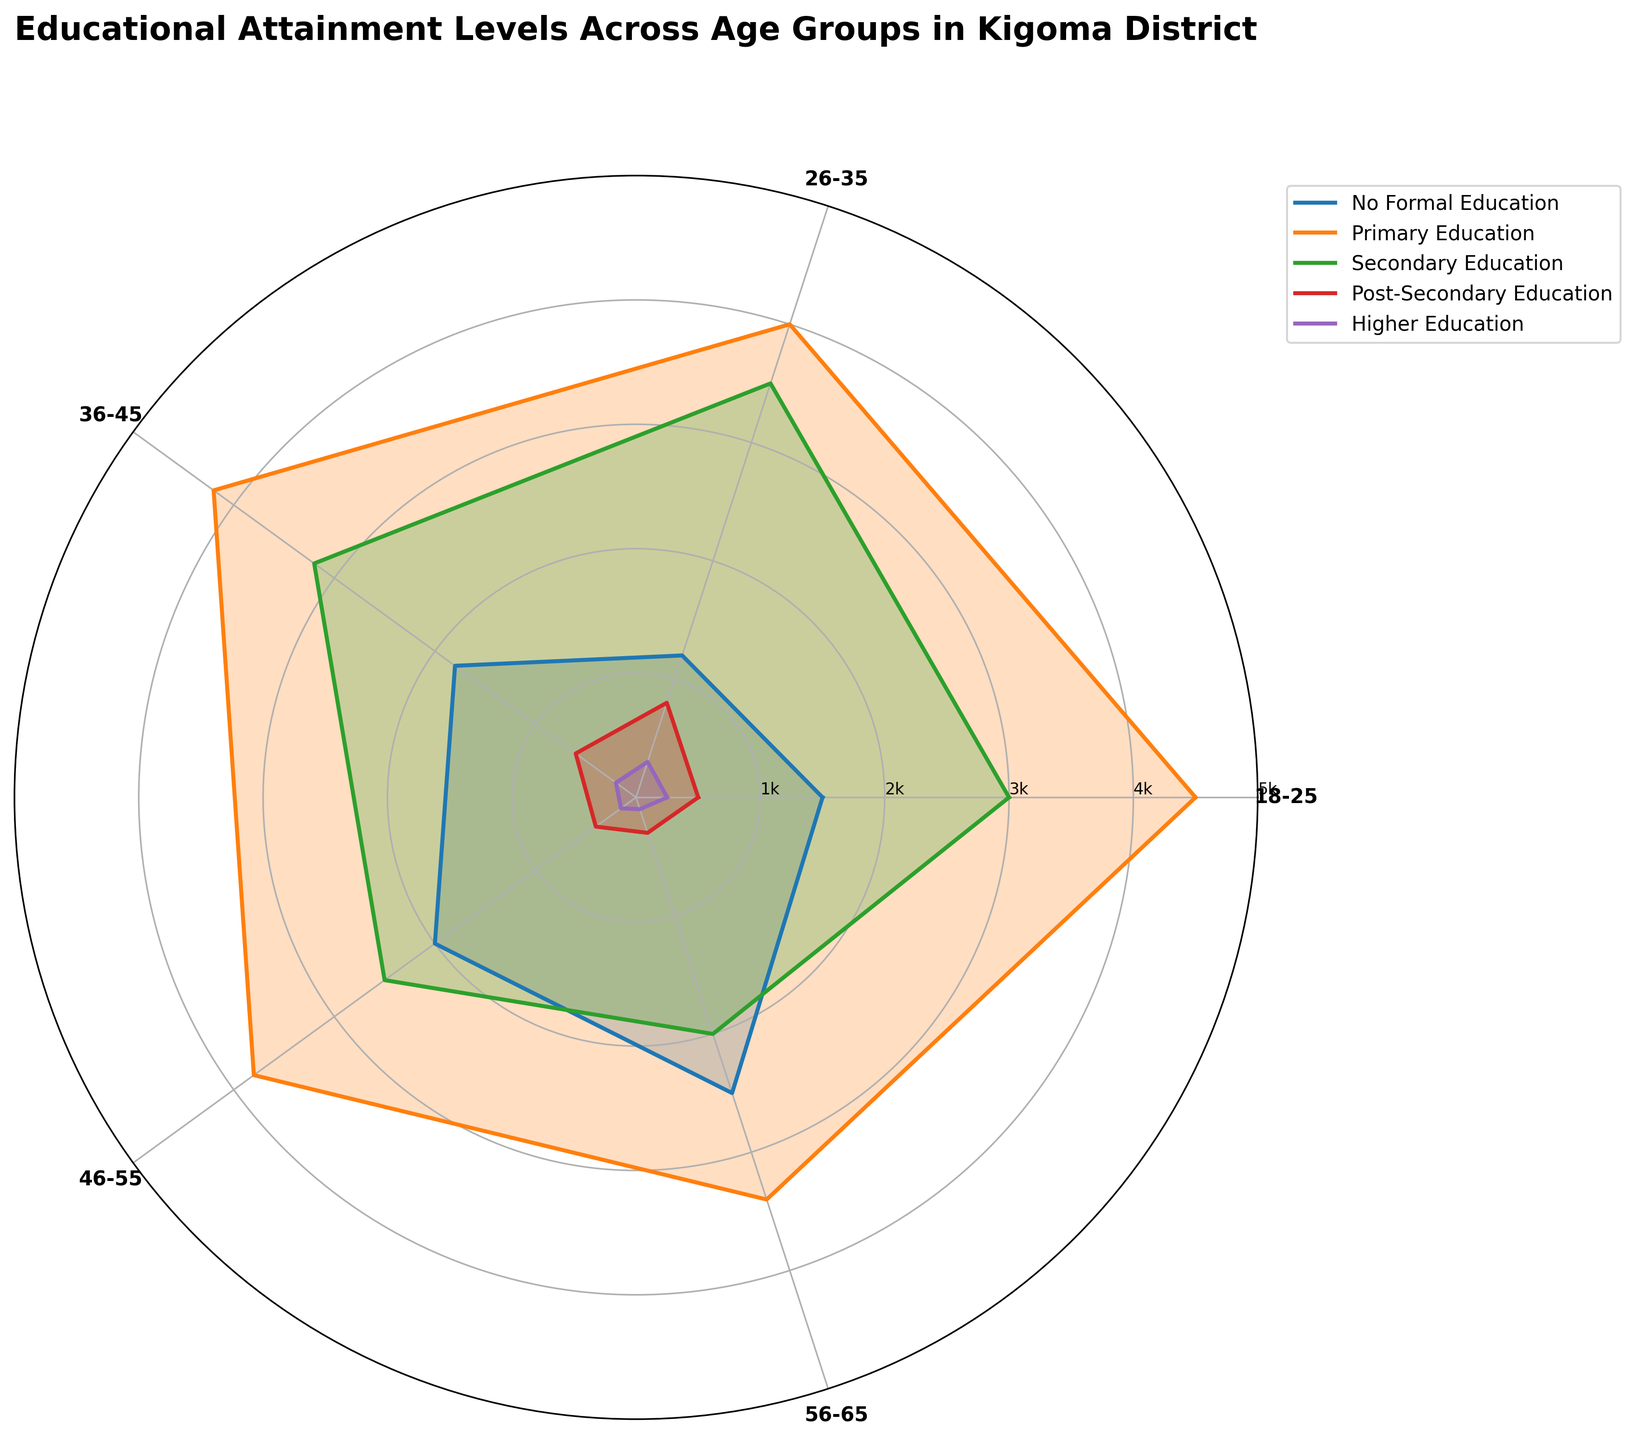What are the different educational attainment levels shown in the plot? The educational attainment levels are visible through the legend and are represented by different line colors and fill areas in the plot. They include No Formal Education, Primary Education, Secondary Education, Post-Secondary Education, and Higher Education.
Answer: No Formal Education, Primary Education, Secondary Education, Post-Secondary Education, Higher Education Which age group has the highest number of individuals with no formal education? By observing the No Formal Education line, it extends the furthest for the 56-65 age group, indicating a higher number of individuals in this category.
Answer: 56-65 How many age groups are represented in the chart? By counting the labeled points on the angular (circular) axis, we can see that there are five age groups represented.
Answer: 5 What is the total number of individuals with secondary education across all age groups? We can sum up the Secondary Education values for each age group: 3000 (18-25) + 3500 (26-35) + 3200 (36-45) + 2500 (46-55) + 2000 (56-65). This results in a total of 14200 individuals.
Answer: 14200 Which age group has the largest difference between primary education and higher education attainment levels? For each age group, we subtract the higher education number from the primary education number:   
18-25: 4500 - 250 = 4250  
26-35: 4000 - 300 = 3700  
36-45: 4200 - 200 = 4000  
46-55: 3800 - 150 = 3650  
56-65: 3400 - 100 = 3300  
The largest difference is for the 18-25 age group.
Answer: 18-25 Which educational level shows a decreasing trend across older age groups? Observing the trend of Higher Education levels across age groups, it shows a decreasing pattern as the age groups advance from 18-25 to 56-65.
Answer: Higher Education How does the number of individuals with secondary education in the 26-35 age group compare to those in the 46-55 age group? The number of individuals with secondary education in the 26-35 age group is 3500, while in the 46-55 age group it is 2500. Thus, the 26-35 age group has 1000 more individuals with secondary education compared to the 46-55 age group.
Answer: 1000 more Which age group has the lowest number of individuals with primary education? By comparing the primary education levels across age groups, the 56-65 age group has the lowest number of individuals (3400).
Answer: 56-65 